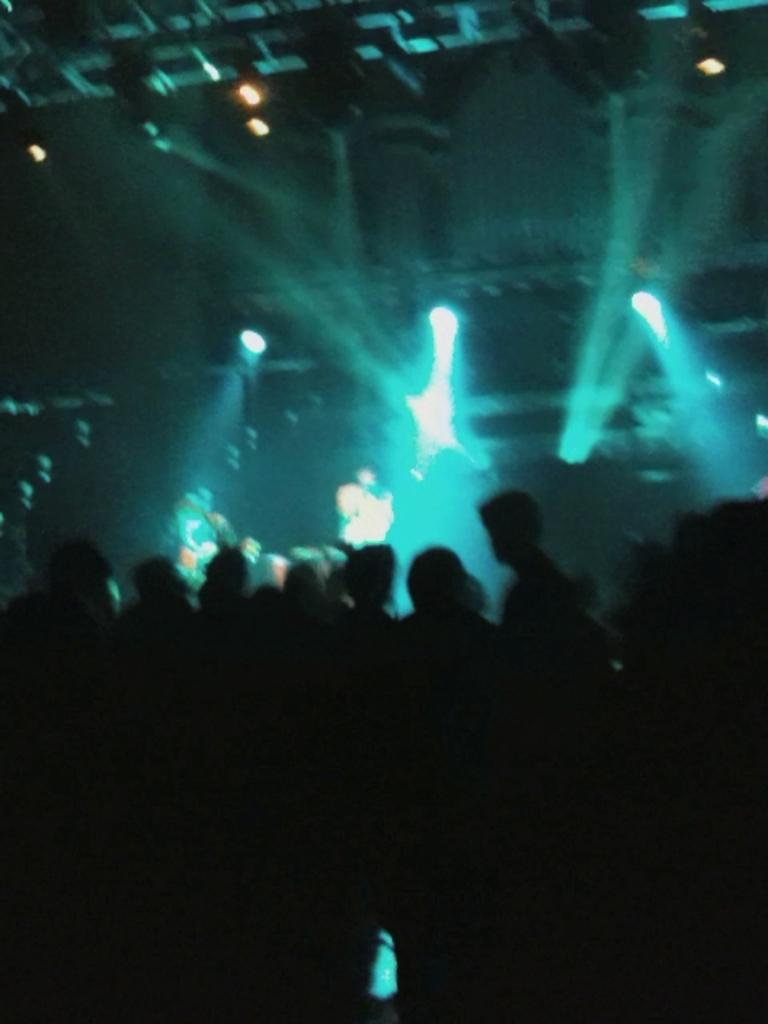What is happening in the image? The image is taken during a live performance. Can you describe the people in the image? There is a crowd standing in the image. What can be seen in the background of the image? Musicians are playing musical instruments in the background. What else is visible in the image? There are lights visible in the image. What type of tree can be seen in the image? There is no tree present in the image; it features a live performance with a crowd and musicians. Can you describe the pot used by the musicians in the image? There is no pot used by the musicians in the image; they are playing musical instruments. 